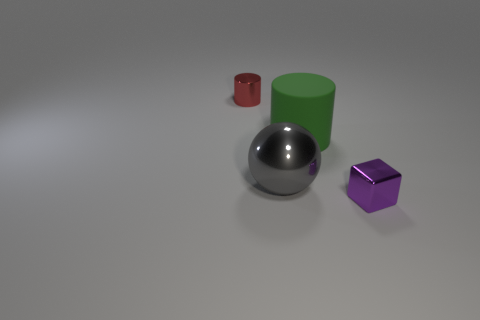Add 2 tiny brown metal blocks. How many objects exist? 6 Subtract all blocks. How many objects are left? 3 Subtract all large cyan cylinders. Subtract all blocks. How many objects are left? 3 Add 3 small purple objects. How many small purple objects are left? 4 Add 4 large cylinders. How many large cylinders exist? 5 Subtract 0 green balls. How many objects are left? 4 